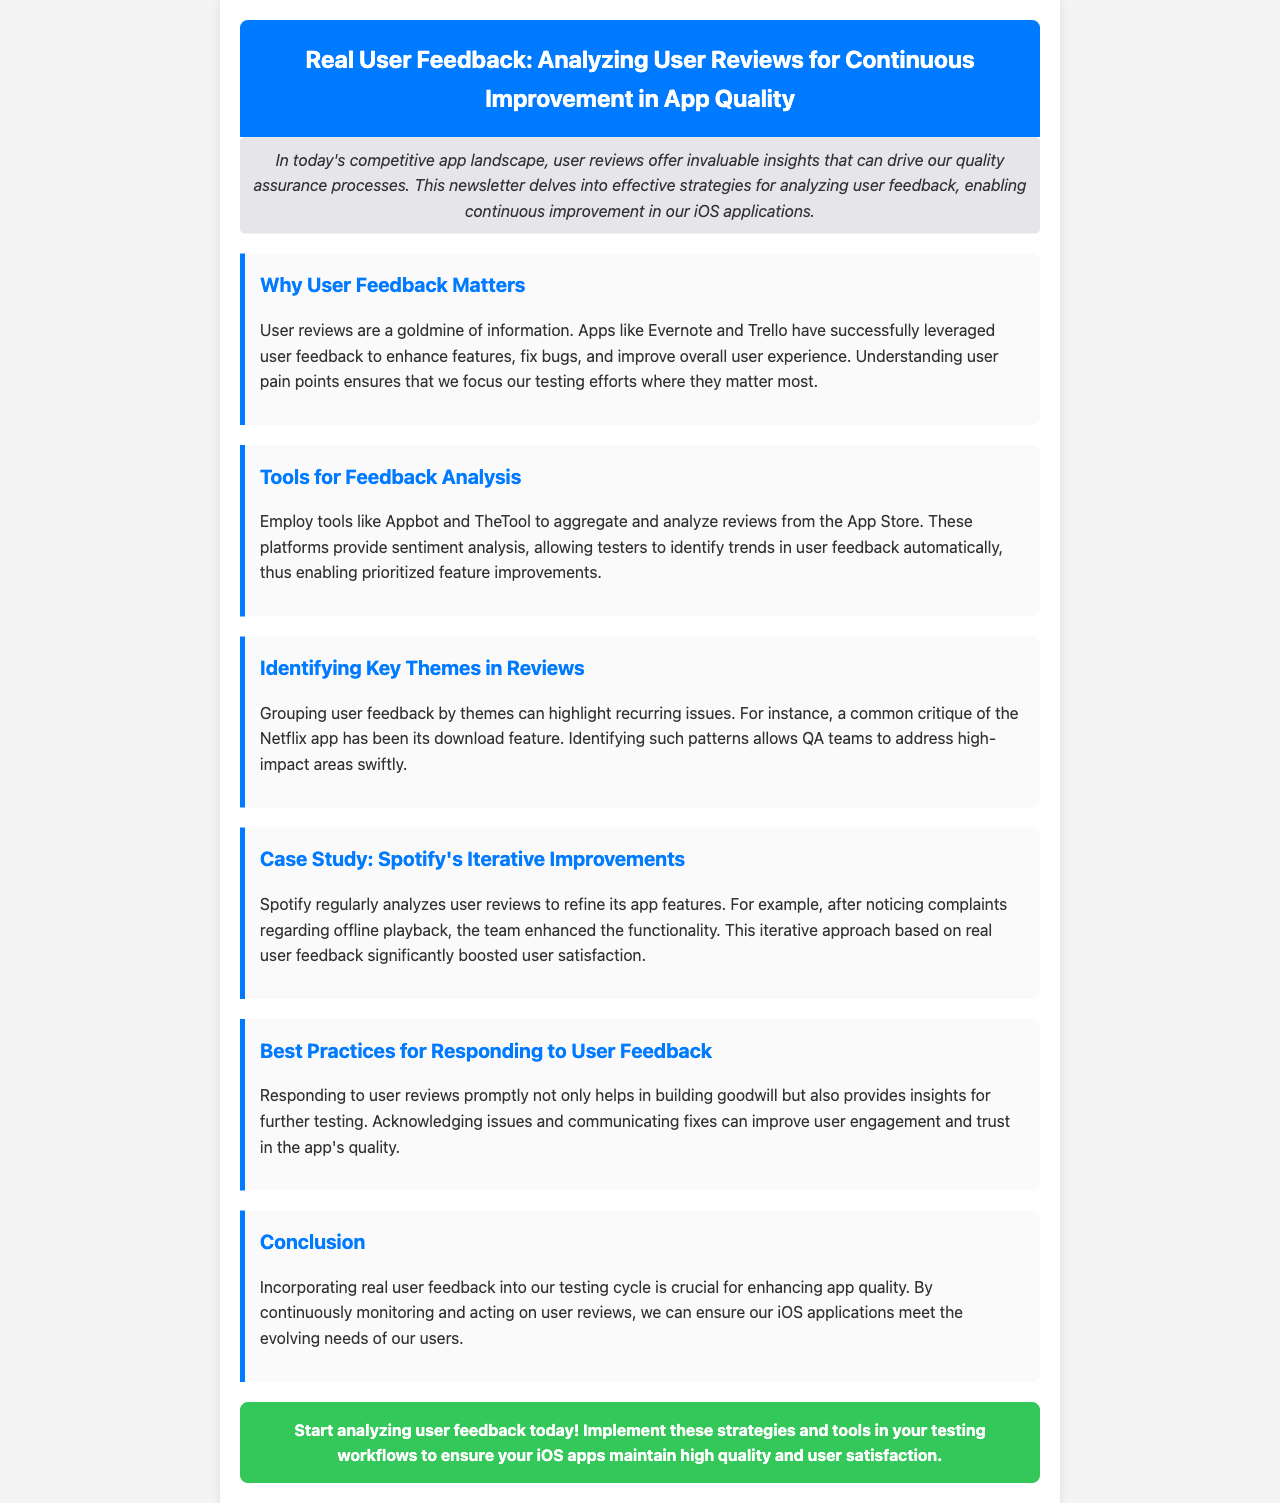What is the title of the newsletter? The title of the newsletter is stated in the header section at the top.
Answer: Real User Feedback: Analyzing User Reviews for Continuous Improvement in App Quality What is the introductory statement about user reviews? The introduction provides insight into the importance of user reviews in enhancing quality assurance processes.
Answer: User reviews offer invaluable insights that can drive our quality assurance processes Which apps are mentioned as having successfully leveraged user feedback? The document specifically mentions two apps that have improved through user feedback.
Answer: Evernote and Trello What tool is suggested for aggregating user reviews? The newsletter recommends a specific tool to help in the analysis of user reviews.
Answer: Appbot What is a common critique of the Netflix app? The document highlights a specific issue that users have identified with the Netflix app.
Answer: Download feature What improvement did Spotify make after analyzing user reviews? The case study of Spotify describes a specific enhancement related to user feedback.
Answer: Offline playback How should testers respond to user feedback according to best practices? The section on best practices outlines how testers should engage with user reviews.
Answer: Promptly What is emphasized as crucial for enhancing app quality? The conclusion highlights a key element for ensuring improved app quality based on user feedback.
Answer: Incorporating real user feedback 